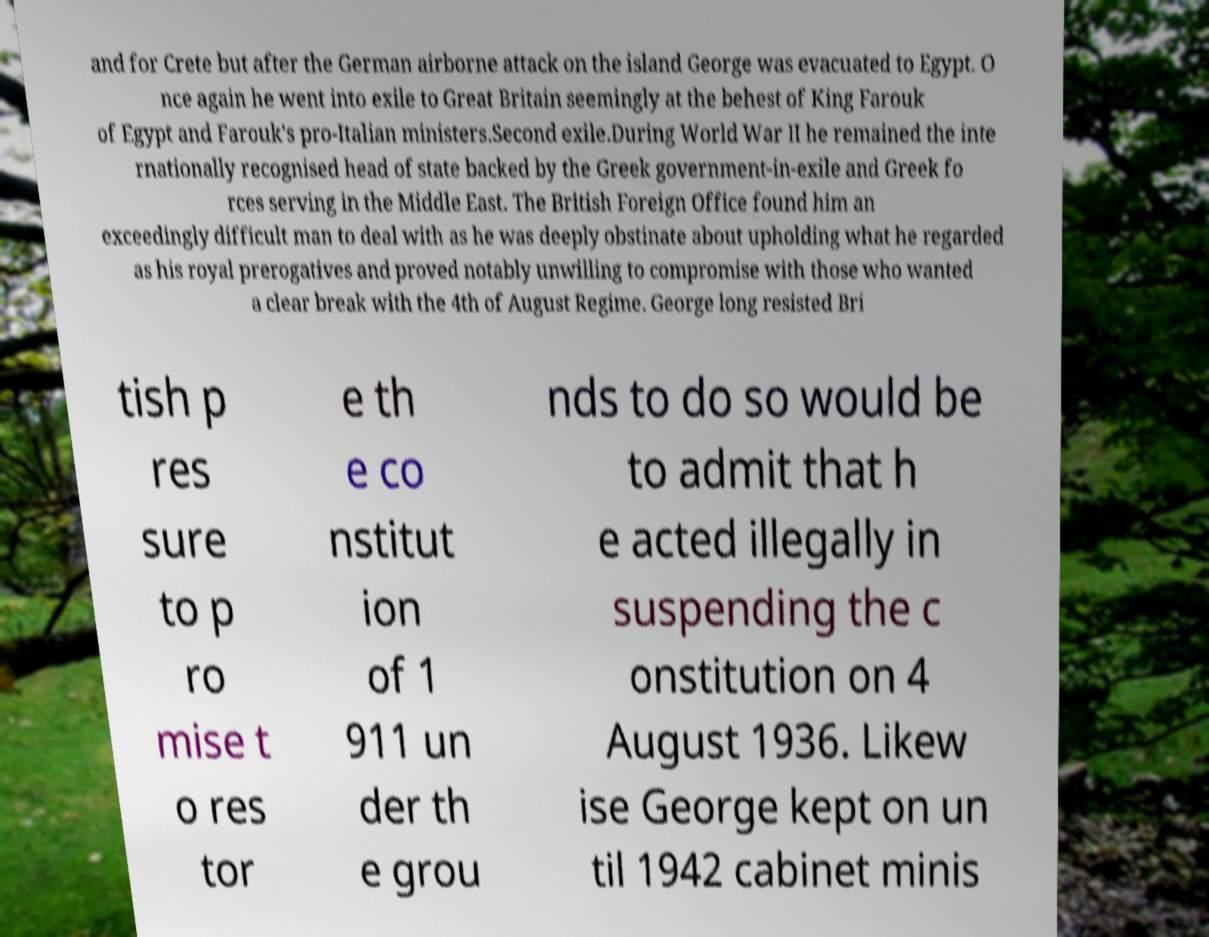Please identify and transcribe the text found in this image. and for Crete but after the German airborne attack on the island George was evacuated to Egypt. O nce again he went into exile to Great Britain seemingly at the behest of King Farouk of Egypt and Farouk's pro-Italian ministers.Second exile.During World War II he remained the inte rnationally recognised head of state backed by the Greek government-in-exile and Greek fo rces serving in the Middle East. The British Foreign Office found him an exceedingly difficult man to deal with as he was deeply obstinate about upholding what he regarded as his royal prerogatives and proved notably unwilling to compromise with those who wanted a clear break with the 4th of August Regime. George long resisted Bri tish p res sure to p ro mise t o res tor e th e co nstitut ion of 1 911 un der th e grou nds to do so would be to admit that h e acted illegally in suspending the c onstitution on 4 August 1936. Likew ise George kept on un til 1942 cabinet minis 